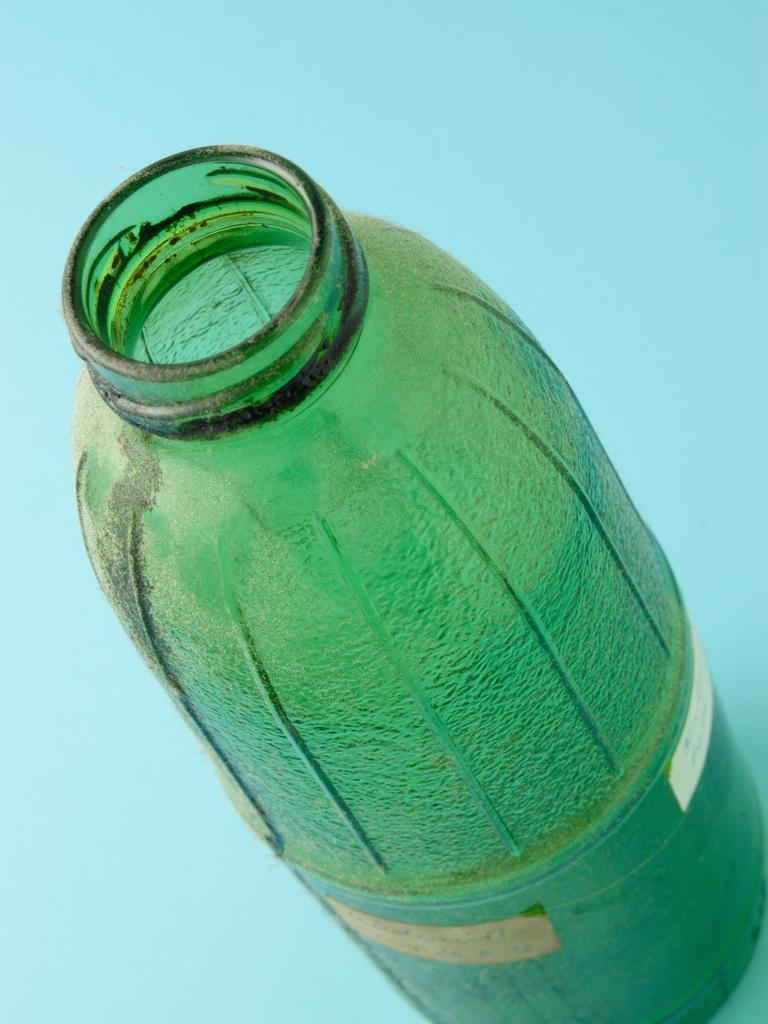What type of object is the main subject in the image? There is a green color glass bottle in the image. How many dimes can be seen inside the glass bottle in the image? There is no mention of dimes in the image, as it only features a green color glass bottle. 